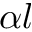Convert formula to latex. <formula><loc_0><loc_0><loc_500><loc_500>\alpha { l }</formula> 